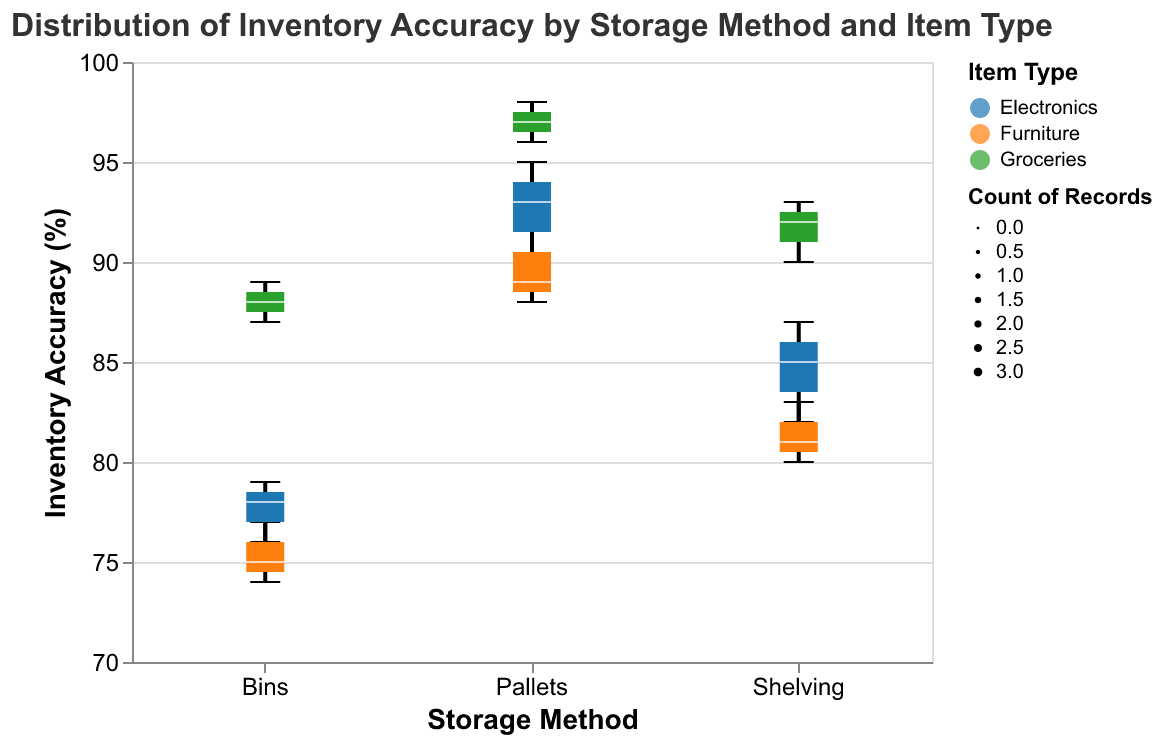What is the title of the figure? The title is generally located at the top of the figure and provides a high-level description of what the figure represents. In this case, it reads "Distribution of Inventory Accuracy by Storage Method and Item Type."
Answer: Distribution of Inventory Accuracy by Storage Method and Item Type Which storage method has the highest median inventory accuracy for groceries? To determine the highest median inventory accuracy for groceries, locate the median line within each box plot for the "Groceries" item type across different storage methods. Compare these values.
Answer: Pallets What is the range of inventory accuracy percentages for electronics stored in bins? To find the range, identify the minimum and maximum values for the "Electronics" item type in the "Bins" storage method. The range is the difference between these two values.
Answer: 76%-79% Which item type and storage method combination has the widest range of inventory accuracy? For each item type and storage method combination, find the range by subtracting the minimum value from the maximum value. Identify which combination has the largest range.
Answer: Shelving, Electronics How many data points are there for groceries stored on pallets? The width representing the count of records is thicker for more data points. Look at the width of the box plot for groceries on pallets, which indicates three data points.
Answer: 3 Between shelving and bins, which storage method has a higher median inventory accuracy for furniture? Compare the median line of the "Furniture" item type for "Shelving" and "Bins" storage methods. Identify which storage method has the higher value.
Answer: Shelving Compare the interquartile range (IQR) of electronics stored on pallets and shelving. Which is larger? The IQR is the range between the first quartile (25th percentile) and the third quartile (75th percentile). Compare the IQR lengths visually between "Electronics" on pallets and shelving.
Answer: Pallets Which storage method generally shows the lowest inventory accuracy for all item types? Evaluate the lower bounds of the box plots for each storage method across all item types to see which method has the lowest values.
Answer: Bins What is the median inventory accuracy for furniture stored on shelving? Find the median line within the box plot for the "Furniture" item type stored using "Shelving."
Answer: 81 Does the "Pallets" storage method show a higher median inventory accuracy for groceries or furniture? Compare the median lines within the box plots for "Groceries" and "Furniture" under the "Pallets" storage method to see which is higher.
Answer: Groceries 